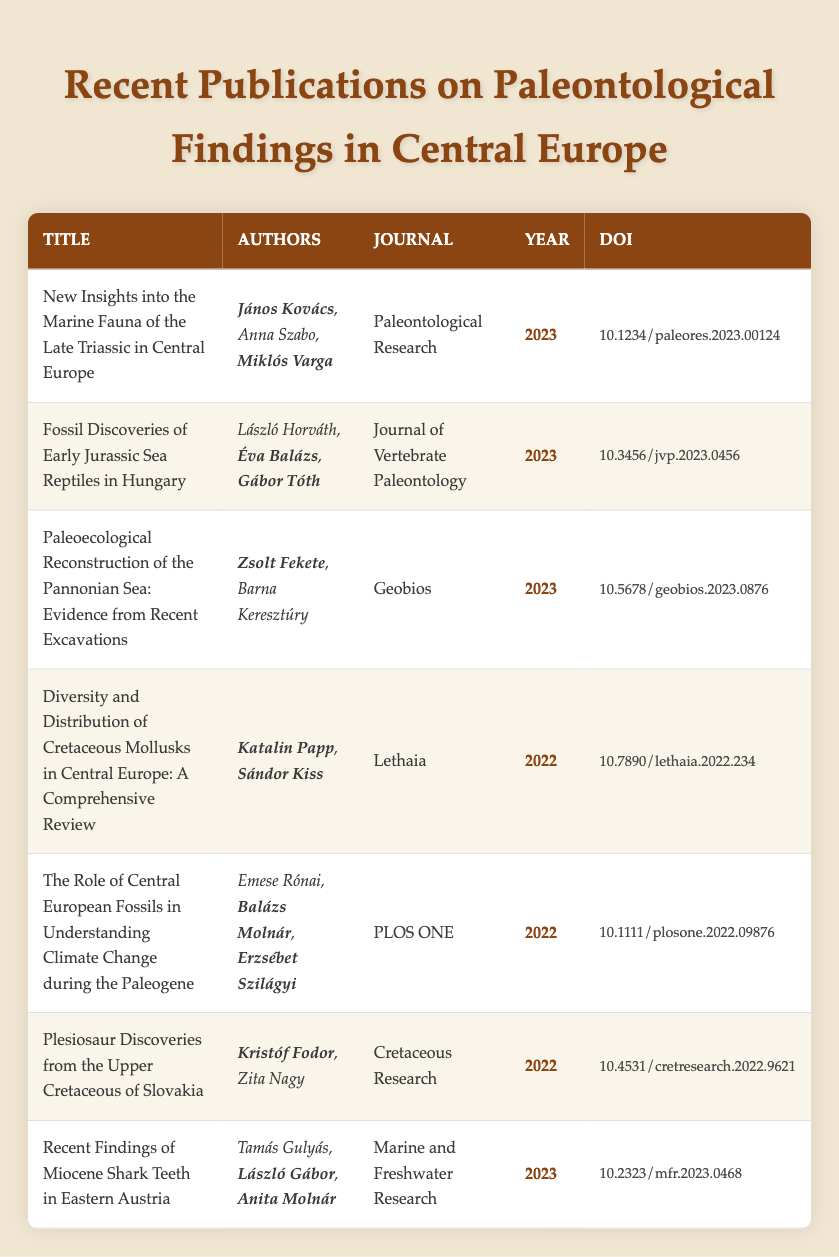What is the title of the publication authored by **János Kovács**? The table lists multiple publications, and by scanning the "Authors" column, the title corresponding to **János Kovács** is "New Insights into the Marine Fauna of the Late Triassic in Central Europe".
Answer: New Insights into the Marine Fauna of the Late Triassic in Central Europe How many publications were released in 2023? By counting the entries in the "Year" column, there are four publications (from 2023).
Answer: 4 Which journal published the work of **Katalin Papp**? In the "Authors" column, **Katalin Papp** is associated with the publication titled "Diversity and Distribution of Cretaceous Mollusks in Central Europe: A Comprehensive Review", which is in the journal "Lethaia".
Answer: Lethaia Did any publication focus on the Miocene period? The titles are examined, and there is a publication titled "Recent Findings of Miocene Shark Teeth in Eastern Austria", indicating that there is a focus on the Miocene period.
Answer: Yes What is the DOI of the publication from "Cretaceous Research"? By locating the journal "Cretaceous Research" in the "Journal" column, the associated DOI found in the table is "10.4531/cretresearch.2022.9621".
Answer: 10.4531/cretresearch.2022.9621 Can you list all authors who published papers in 2022? By scanning the "Year" column for 2022 and checking the corresponding "Authors" column, the authors are **Katalin Papp**, **Sándor Kiss**, **Balázs Molnár**, **Erzsébet Szilágyi**, **Kristóf Fodor**, and Zita Nagy.
Answer: **Katalin Papp**, **Sándor Kiss**, **Balázs Molnár**, **Erzsébet Szilágyi**, **Kristóf Fodor**, Zita Nagy Which authors collaborated on a publication regarding Early Jurassic Sea Reptiles? The title "Fossil Discoveries of Early Jurassic Sea Reptiles in Hungary" shows that the authors are **Éva Balázs** and **Gábor Tóth** alongside László Horváth.
Answer: **Éva Balázs**, **Gábor Tóth** Which publication had the most recent findings? By checking the "Year" column entries, the latest year is 2023, so the publications from that year are considered recent, which includes "New Insights into the Marine Fauna of the Late Triassic in Central Europe", "Fossil Discoveries of Early Jurassic Sea Reptiles in Hungary", "Paleoecological Reconstruction of the Pannonian Sea", and "Recent Findings of Miocene Shark Teeth in Eastern Austria".
Answer: "New Insights into the Marine Fauna of the Late Triassic in Central Europe", "Fossil Discoveries of Early Jurassic Sea Reptiles in Hungary", "Paleoecological Reconstruction of the Pannonian Sea", "Recent Findings of Miocene Shark Teeth in Eastern Austria" What is the average publication year in the table? The years involved are 2023, 2023, 2023, 2022, 2022, 2022, and 2023. Summing these yields (3*2023 + 3*2022) = 6069 + 6066 = 12135. Dividing by 7 gives an average of approximately 2022.14, hence the rounded average year is 2022.
Answer: 2022 Which publication had **Balázs Molnár** as an author? Scanning the "Authors" column reveals that **Balázs Molnár** contributed to the publication titled "The Role of Central European Fossils in Understanding Climate Change during the Paleogene".
Answer: The Role of Central European Fossils in Understanding Climate Change during the Paleogene 